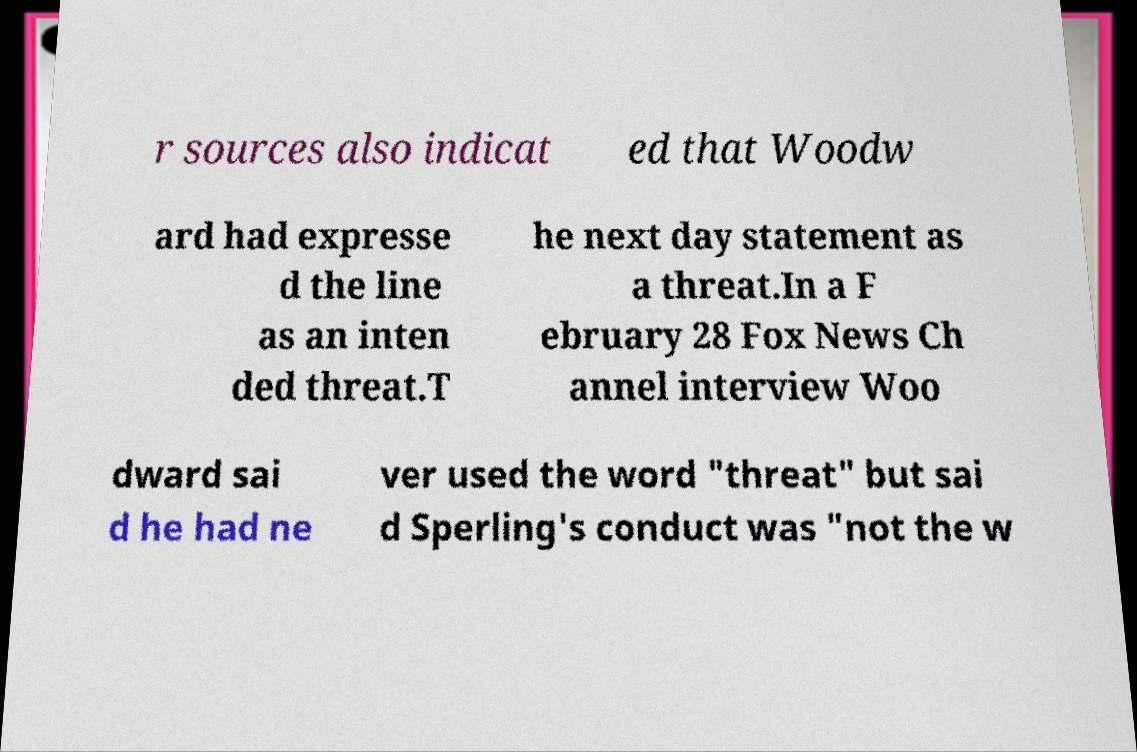Please identify and transcribe the text found in this image. r sources also indicat ed that Woodw ard had expresse d the line as an inten ded threat.T he next day statement as a threat.In a F ebruary 28 Fox News Ch annel interview Woo dward sai d he had ne ver used the word "threat" but sai d Sperling's conduct was "not the w 